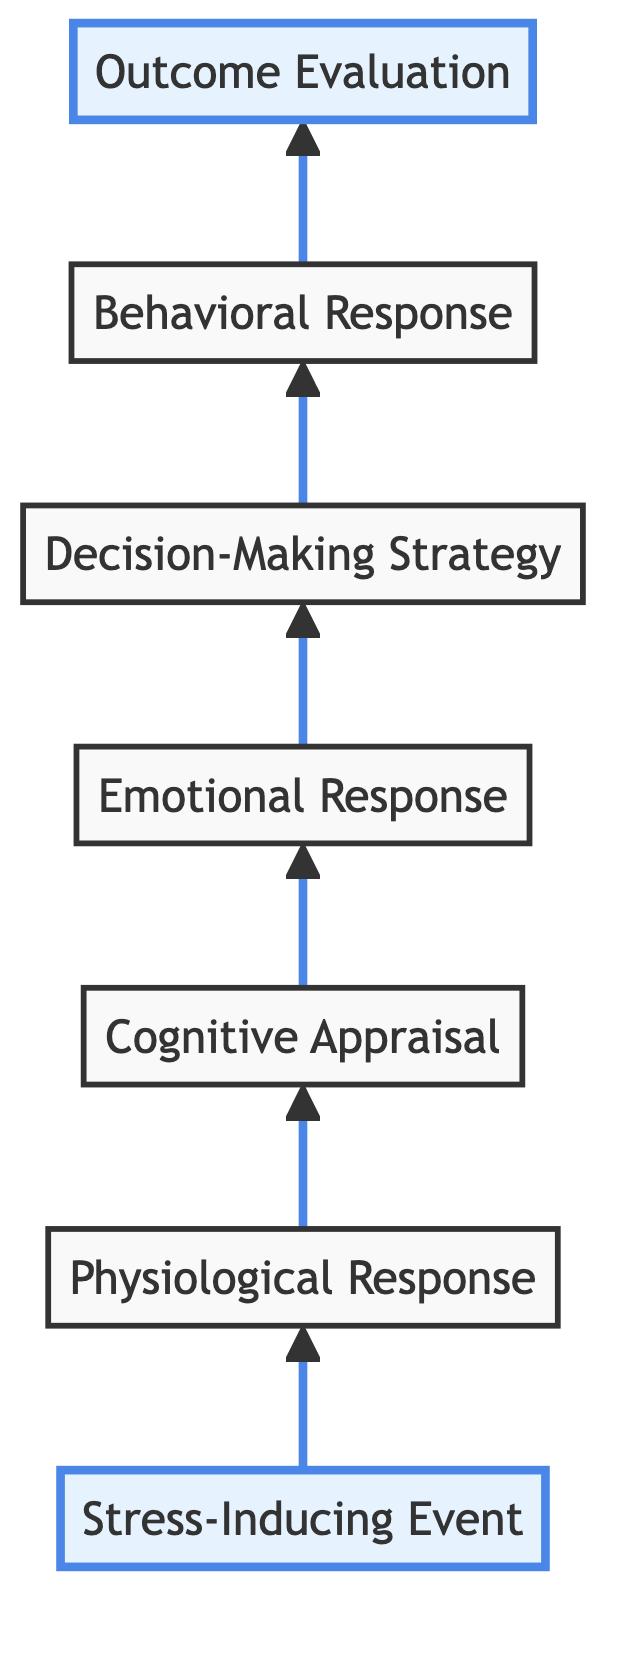What is the first node in the diagram? The first node in the Bottom to Top Flow Chart is labeled "Stress-Inducing Event." It is positioned at level 1 and represents the starting point of the decision-making process under stress.
Answer: Stress-Inducing Event What is the seventh node of the flow chart? The seventh node is "Outcome Evaluation," which is located at level 7. This node concludes the flow and evaluates the result of previous actions in dealing with stress.
Answer: Outcome Evaluation How many total nodes are present in the diagram? There are a total of seven nodes in the flow chart. Each node corresponds to a step in the decision-making process under stress, from the initial event to the final evaluation.
Answer: 7 What emotion is associated with the emotional response node? The emotional response node can include emotions such as fear, anxiety, frustration, or determination. This is derived from the description of the node, which highlights common emotional experiences in response to stress.
Answer: Fear, anxiety, frustration, determination What follows "Physiological Response" in the flow chart? Following "Physiological Response," the next node is "Cognitive Appraisal." This indicates that after the physiological responses to stress occur, the individual evaluates the situation mentally.
Answer: Cognitive Appraisal Which response strategy is influenced by the level of stress? The "Decision-Making Strategy" is influenced by the level of stress as well as individual differences. This node highlights that the choice of strategy changes based on the intensity of the stress experienced.
Answer: Decision-Making Strategy If the "Behavioral Response" is ineffective, what may happen in the outcome evaluation? If the "Behavioral Response" is ineffective, the outcome evaluation may indicate a lack of emotional relief and potential learning for future events. This is based on the description which mentions evaluating the effectiveness of responses.
Answer: Lack of emotional relief How does the physiological response affect cognitive appraisal? The physiological response affects cognitive appraisal by heightening alertness and influencing how individuals evaluate the severity of a stressor and their coping resources. This connection emphasizes the psychological process following physical changes.
Answer: Heightened alertness What is the relationship between "Decision-Making Strategy" and "Behavioral Response"? The relationship is that the "Decision-Making Strategy" directly leads to the "Behavioral Response." This shows a sequential action where the chosen strategy dictates the observable actions taken in response to stress.
Answer: Directly leads to 